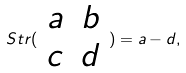<formula> <loc_0><loc_0><loc_500><loc_500>S t r ( \begin{array} { c c } a & b \\ c & d \end{array} ) = a - d ,</formula> 